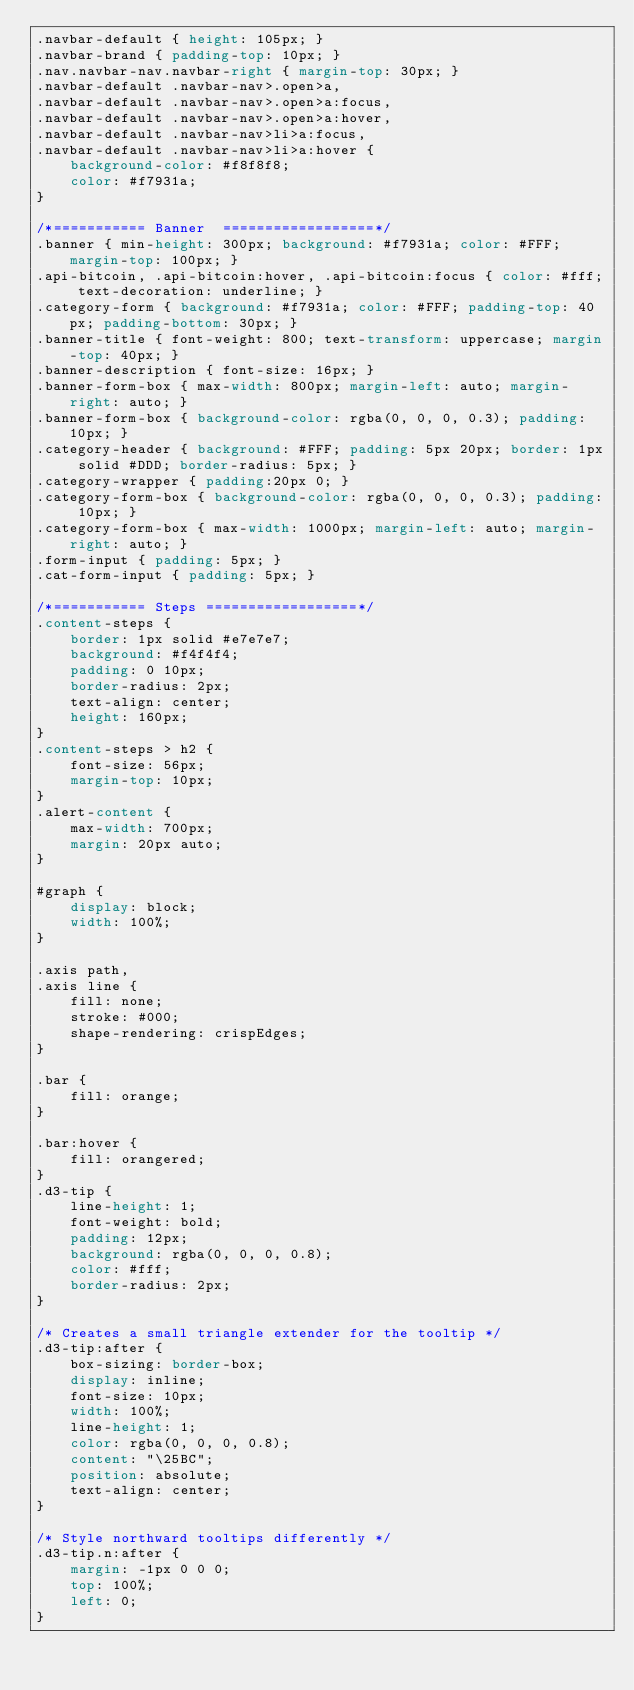<code> <loc_0><loc_0><loc_500><loc_500><_CSS_>.navbar-default { height: 105px; }
.navbar-brand { padding-top: 10px; }
.nav.navbar-nav.navbar-right { margin-top: 30px; }
.navbar-default .navbar-nav>.open>a,
.navbar-default .navbar-nav>.open>a:focus,
.navbar-default .navbar-nav>.open>a:hover,
.navbar-default .navbar-nav>li>a:focus,
.navbar-default .navbar-nav>li>a:hover {
    background-color: #f8f8f8;
    color: #f7931a;
}

/*=========== Banner  ==================*/
.banner { min-height: 300px; background: #f7931a; color: #FFF; margin-top: 100px; }
.api-bitcoin, .api-bitcoin:hover, .api-bitcoin:focus { color: #fff; text-decoration: underline; }
.category-form { background: #f7931a; color: #FFF; padding-top: 40px; padding-bottom: 30px; }
.banner-title { font-weight: 800; text-transform: uppercase; margin-top: 40px; }
.banner-description { font-size: 16px; }
.banner-form-box { max-width: 800px; margin-left: auto; margin-right: auto; }
.banner-form-box { background-color: rgba(0, 0, 0, 0.3); padding: 10px; }
.category-header { background: #FFF; padding: 5px 20px; border: 1px solid #DDD; border-radius: 5px; }
.category-wrapper { padding:20px 0; }
.category-form-box { background-color: rgba(0, 0, 0, 0.3); padding: 10px; }
.category-form-box { max-width: 1000px; margin-left: auto; margin-right: auto; }
.form-input { padding: 5px; }
.cat-form-input { padding: 5px; }

/*=========== Steps ==================*/
.content-steps {
    border: 1px solid #e7e7e7;
    background: #f4f4f4;
    padding: 0 10px;
    border-radius: 2px;
    text-align: center;
    height: 160px;
}
.content-steps > h2 {
    font-size: 56px;
    margin-top: 10px;
}
.alert-content {
    max-width: 700px;
    margin: 20px auto;
}

#graph {
    display: block;
    width: 100%;
}

.axis path,
.axis line {
    fill: none;
    stroke: #000;
    shape-rendering: crispEdges;
}

.bar {
    fill: orange;
}

.bar:hover {
    fill: orangered;
}
.d3-tip {
    line-height: 1;
    font-weight: bold;
    padding: 12px;
    background: rgba(0, 0, 0, 0.8);
    color: #fff;
    border-radius: 2px;
}

/* Creates a small triangle extender for the tooltip */
.d3-tip:after {
    box-sizing: border-box;
    display: inline;
    font-size: 10px;
    width: 100%;
    line-height: 1;
    color: rgba(0, 0, 0, 0.8);
    content: "\25BC";
    position: absolute;
    text-align: center;
}

/* Style northward tooltips differently */
.d3-tip.n:after {
    margin: -1px 0 0 0;
    top: 100%;
    left: 0;
}
</code> 